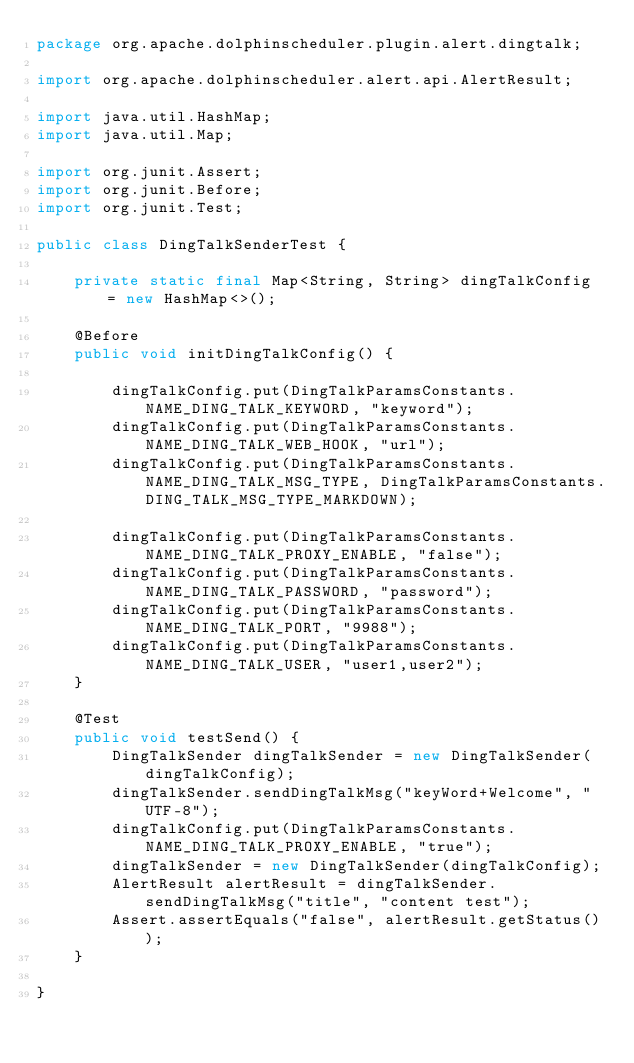Convert code to text. <code><loc_0><loc_0><loc_500><loc_500><_Java_>package org.apache.dolphinscheduler.plugin.alert.dingtalk;

import org.apache.dolphinscheduler.alert.api.AlertResult;

import java.util.HashMap;
import java.util.Map;

import org.junit.Assert;
import org.junit.Before;
import org.junit.Test;

public class DingTalkSenderTest {

    private static final Map<String, String> dingTalkConfig = new HashMap<>();

    @Before
    public void initDingTalkConfig() {

        dingTalkConfig.put(DingTalkParamsConstants.NAME_DING_TALK_KEYWORD, "keyword");
        dingTalkConfig.put(DingTalkParamsConstants.NAME_DING_TALK_WEB_HOOK, "url");
        dingTalkConfig.put(DingTalkParamsConstants.NAME_DING_TALK_MSG_TYPE, DingTalkParamsConstants.DING_TALK_MSG_TYPE_MARKDOWN);

        dingTalkConfig.put(DingTalkParamsConstants.NAME_DING_TALK_PROXY_ENABLE, "false");
        dingTalkConfig.put(DingTalkParamsConstants.NAME_DING_TALK_PASSWORD, "password");
        dingTalkConfig.put(DingTalkParamsConstants.NAME_DING_TALK_PORT, "9988");
        dingTalkConfig.put(DingTalkParamsConstants.NAME_DING_TALK_USER, "user1,user2");
    }

    @Test
    public void testSend() {
        DingTalkSender dingTalkSender = new DingTalkSender(dingTalkConfig);
        dingTalkSender.sendDingTalkMsg("keyWord+Welcome", "UTF-8");
        dingTalkConfig.put(DingTalkParamsConstants.NAME_DING_TALK_PROXY_ENABLE, "true");
        dingTalkSender = new DingTalkSender(dingTalkConfig);
        AlertResult alertResult = dingTalkSender.sendDingTalkMsg("title", "content test");
        Assert.assertEquals("false", alertResult.getStatus());
    }

}
</code> 